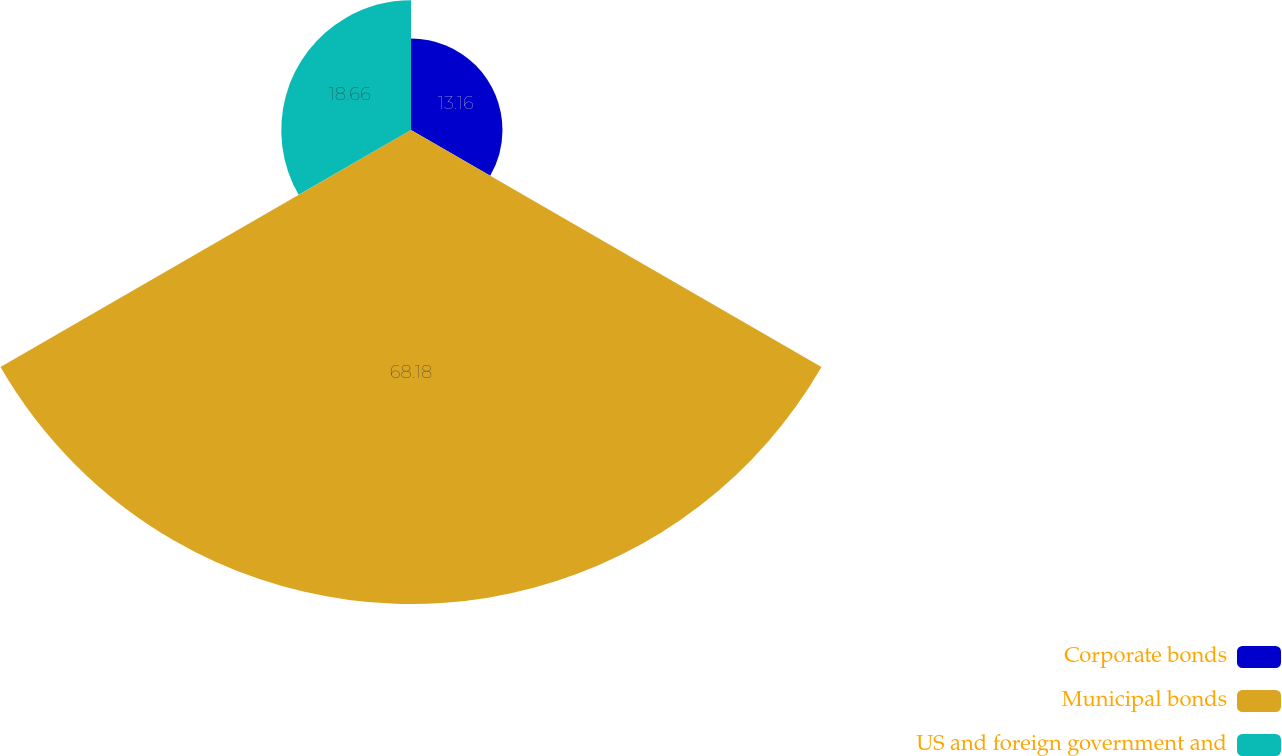Convert chart. <chart><loc_0><loc_0><loc_500><loc_500><pie_chart><fcel>Corporate bonds<fcel>Municipal bonds<fcel>US and foreign government and<nl><fcel>13.16%<fcel>68.18%<fcel>18.66%<nl></chart> 